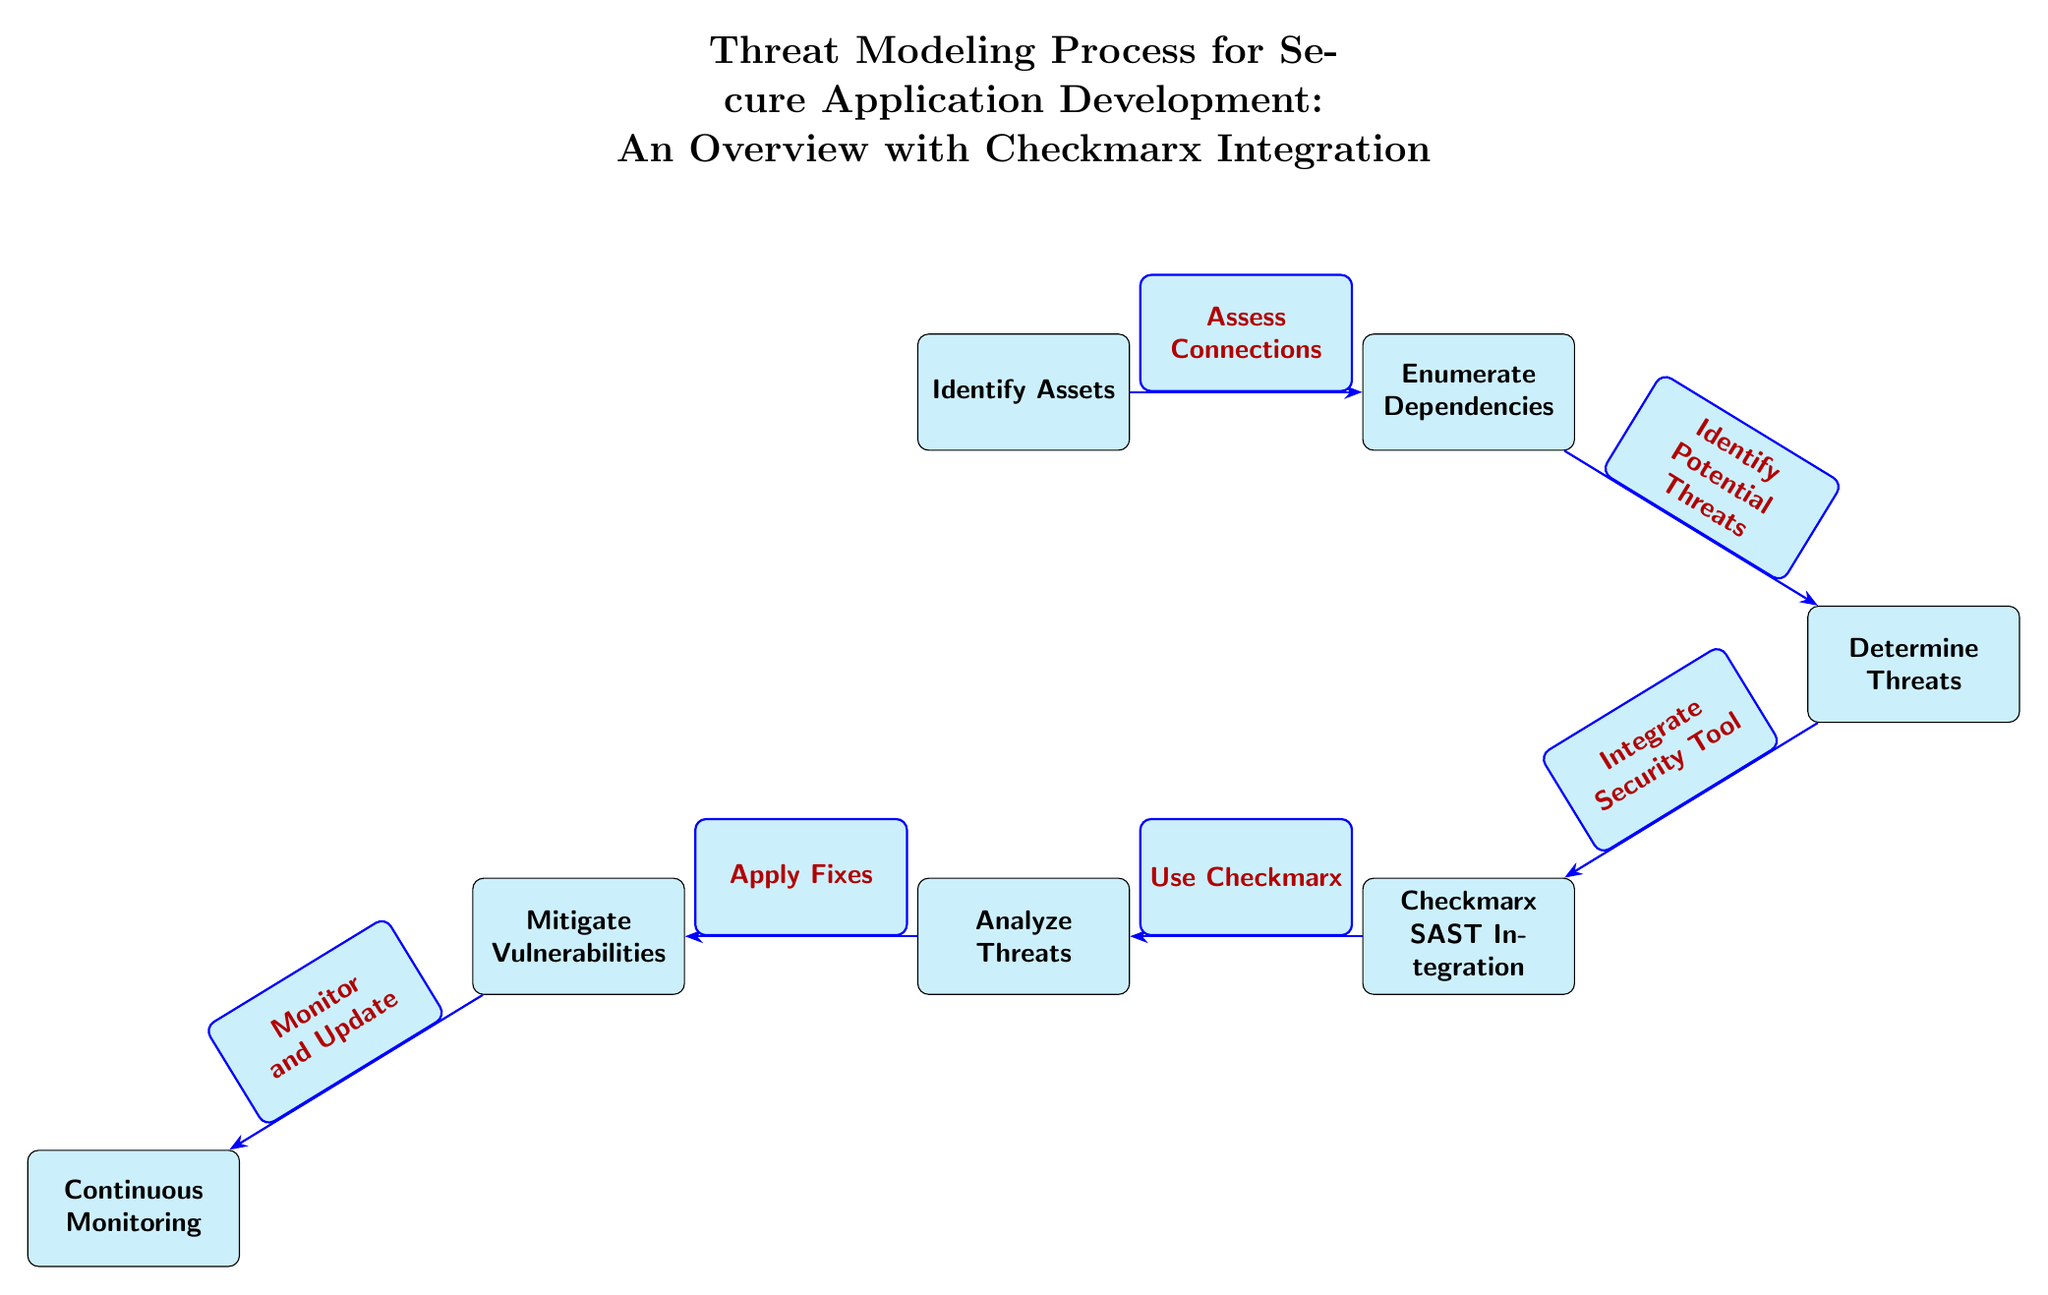What is the first step in the threat modeling process? The first step in the diagram is labeled as "Identify Assets," which is positioned at the top left of the flow.
Answer: Identify Assets How many nodes are present in the diagram? By counting the distinct labeled boxes, there are a total of seven nodes represented in the diagram.
Answer: Seven What is the relationship between "Determine Threats" and "Analyze Threats"? The edge connecting these two nodes is directed from "Determine Threats" to "Analyze Threats," indicating that analyzing follows after determining the threats.
Answer: Direct relationship Which step involves the use of Checkmarx? The node labeled "Use Checkmarx" directly follows the "Checkmarx SAST Integration" node, indicating that this step is where Checkmarx is utilized in the process.
Answer: Use Checkmarx What action follows after mitigating vulnerabilities? According to the diagram, the action that follows "Mitigate Vulnerabilities" is "Continuous Monitoring," representing the next step in ensuring ongoing security.
Answer: Continuous Monitoring How does the process connect "Identify Assets" to "Enumerate Dependencies"? The relationship is shown by a directed edge labeled "Assess Connections," indicating that identifying assets is assessed to enumerate dependencies.
Answer: Assess Connections What is the last step in the threat modeling process? The final node located at the bottom of the diagram is labeled "Continuous Monitoring," representing the last step of the process flow.
Answer: Continuous Monitoring What is the purpose of the "Analyze Threats" step? The purpose of this step is to evaluate identified threats prior to creating mitigation strategies, ensuring thorough examination before action.
Answer: Evaluate identified threats What is the direction of the flow from "Enumerate Dependencies"? The flow moves from "Enumerate Dependencies" to "Determine Threats," indicating that the enumeration of dependencies directly informs threat determination.
Answer: To Determine Threats 